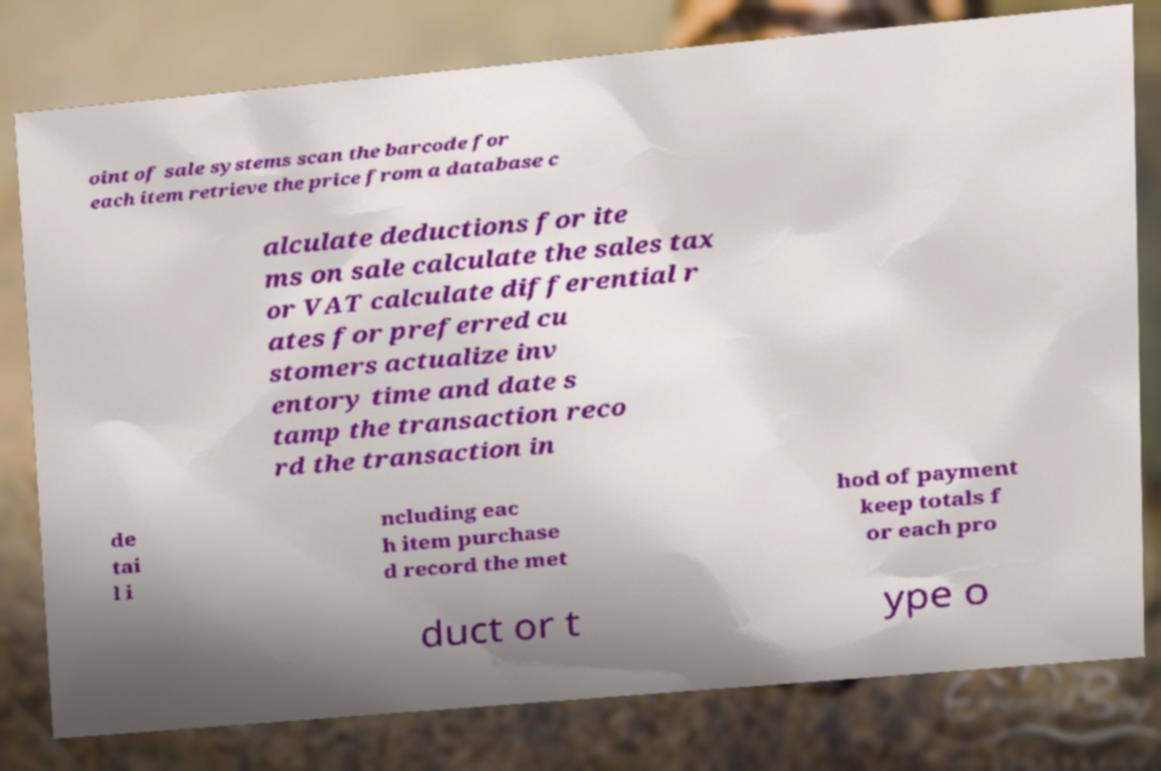What messages or text are displayed in this image? I need them in a readable, typed format. oint of sale systems scan the barcode for each item retrieve the price from a database c alculate deductions for ite ms on sale calculate the sales tax or VAT calculate differential r ates for preferred cu stomers actualize inv entory time and date s tamp the transaction reco rd the transaction in de tai l i ncluding eac h item purchase d record the met hod of payment keep totals f or each pro duct or t ype o 